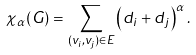<formula> <loc_0><loc_0><loc_500><loc_500>\chi _ { \alpha } ( G ) = \sum _ { ( v _ { i } , v _ { j } ) \in E } \left ( d _ { i } + d _ { j } \right ) ^ { \alpha } .</formula> 